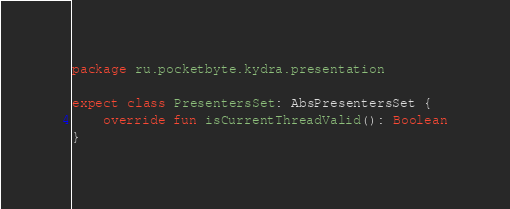Convert code to text. <code><loc_0><loc_0><loc_500><loc_500><_Kotlin_>package ru.pocketbyte.kydra.presentation

expect class PresentersSet: AbsPresentersSet {
    override fun isCurrentThreadValid(): Boolean
}</code> 